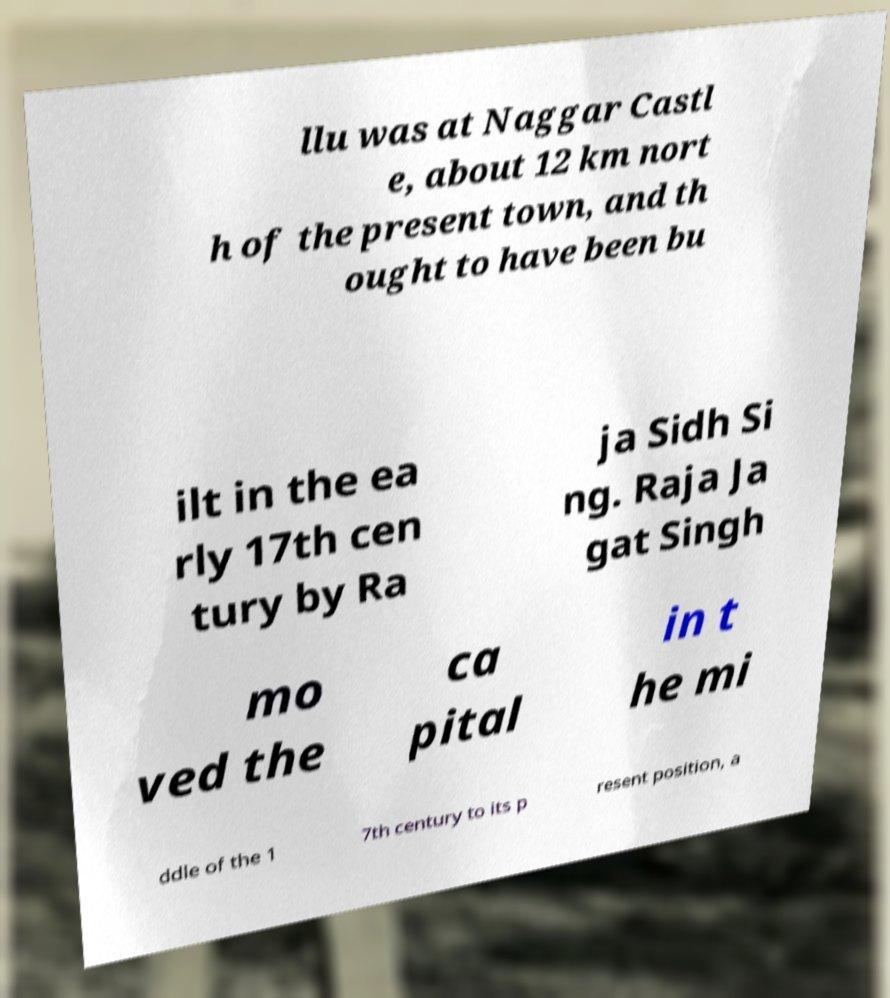Please read and relay the text visible in this image. What does it say? llu was at Naggar Castl e, about 12 km nort h of the present town, and th ought to have been bu ilt in the ea rly 17th cen tury by Ra ja Sidh Si ng. Raja Ja gat Singh mo ved the ca pital in t he mi ddle of the 1 7th century to its p resent position, a 